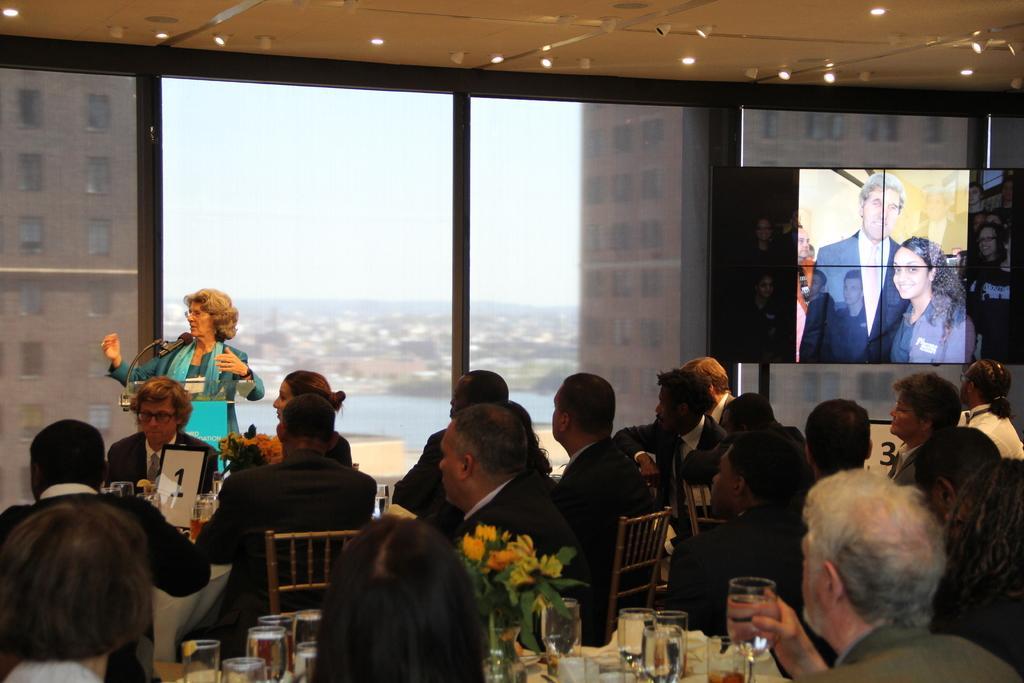Could you give a brief overview of what you see in this image? As we can see in the image, there are few people sitting on chairs and there is a table here. On table there is a flower, glasses and the woman who was standing over here is talking on mike. 